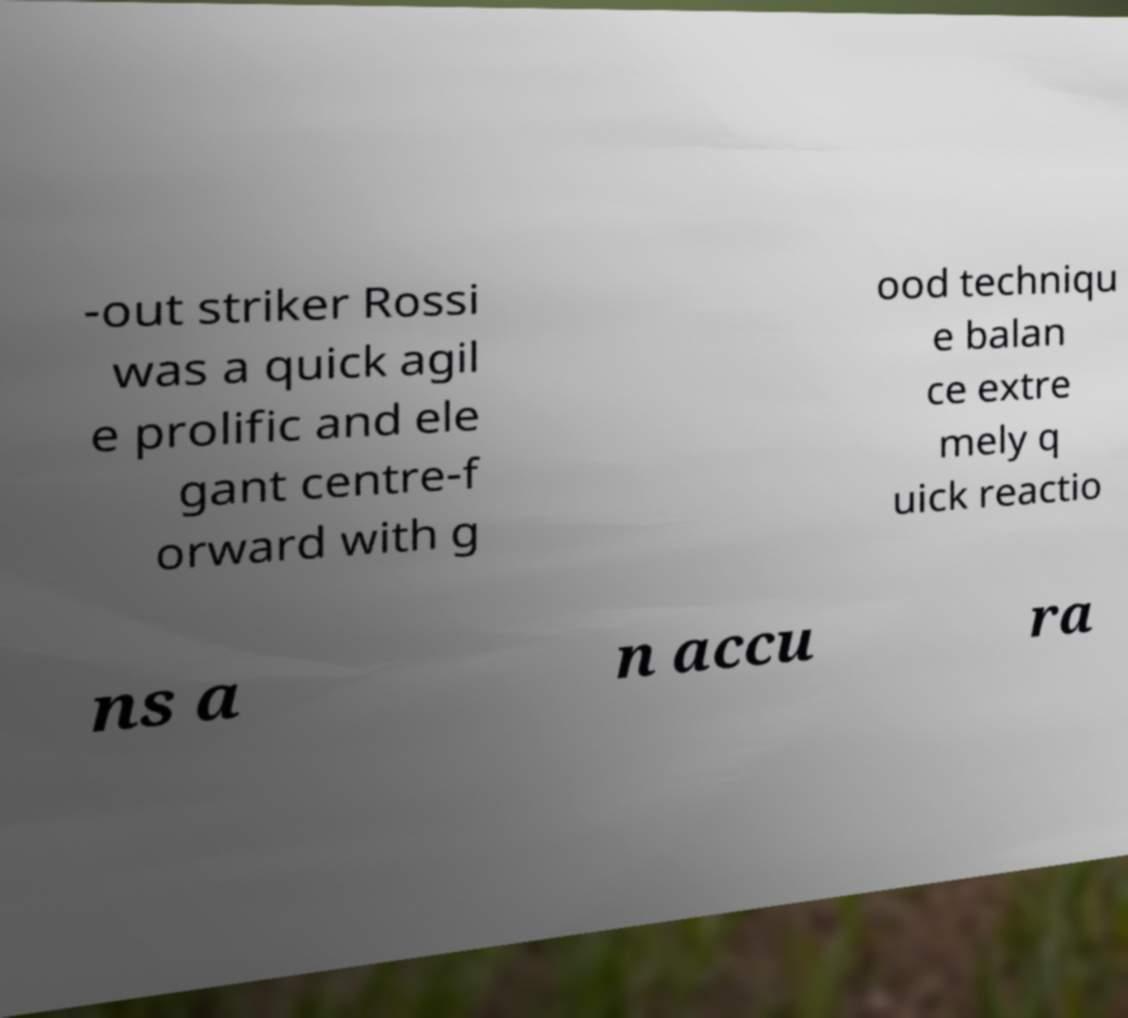Can you read and provide the text displayed in the image?This photo seems to have some interesting text. Can you extract and type it out for me? -out striker Rossi was a quick agil e prolific and ele gant centre-f orward with g ood techniqu e balan ce extre mely q uick reactio ns a n accu ra 